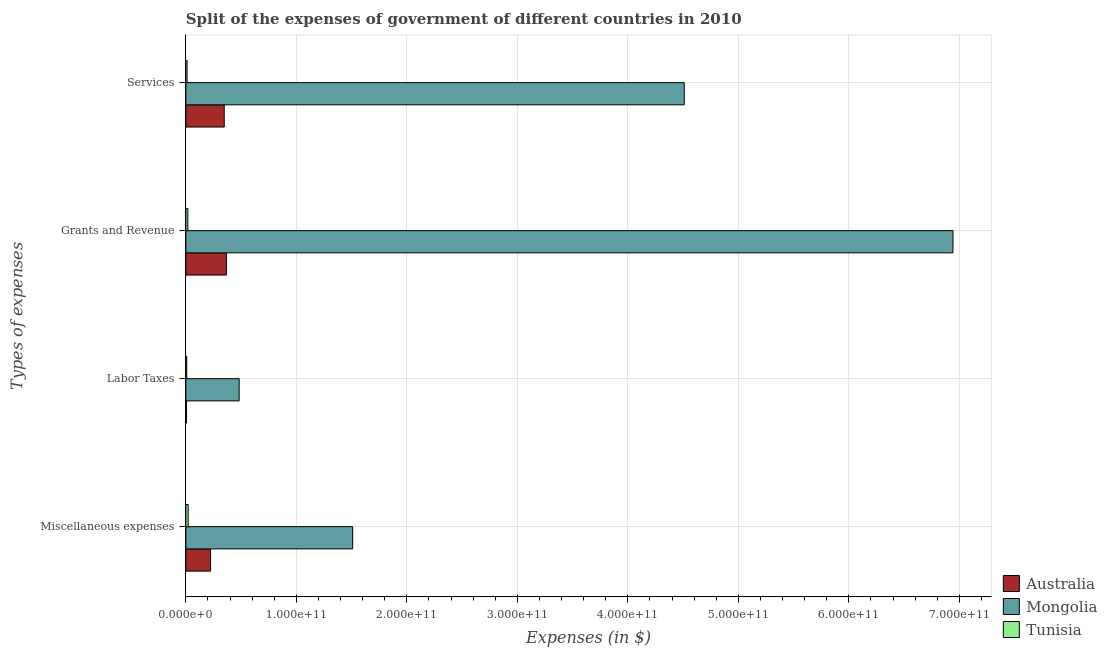How many groups of bars are there?
Keep it short and to the point. 4. Are the number of bars per tick equal to the number of legend labels?
Your answer should be compact. Yes. Are the number of bars on each tick of the Y-axis equal?
Your answer should be compact. Yes. How many bars are there on the 3rd tick from the bottom?
Your answer should be very brief. 3. What is the label of the 1st group of bars from the top?
Your answer should be compact. Services. What is the amount spent on services in Tunisia?
Make the answer very short. 1.09e+09. Across all countries, what is the maximum amount spent on services?
Your response must be concise. 4.51e+11. Across all countries, what is the minimum amount spent on labor taxes?
Ensure brevity in your answer.  5.19e+08. In which country was the amount spent on services maximum?
Make the answer very short. Mongolia. What is the total amount spent on services in the graph?
Keep it short and to the point. 4.87e+11. What is the difference between the amount spent on grants and revenue in Tunisia and that in Australia?
Ensure brevity in your answer.  -3.49e+1. What is the difference between the amount spent on services in Mongolia and the amount spent on labor taxes in Australia?
Make the answer very short. 4.51e+11. What is the average amount spent on services per country?
Ensure brevity in your answer.  1.62e+11. What is the difference between the amount spent on services and amount spent on grants and revenue in Mongolia?
Your answer should be very brief. -2.43e+11. In how many countries, is the amount spent on services greater than 660000000000 $?
Give a very brief answer. 0. What is the ratio of the amount spent on miscellaneous expenses in Australia to that in Tunisia?
Provide a succinct answer. 10.77. What is the difference between the highest and the second highest amount spent on miscellaneous expenses?
Provide a succinct answer. 1.29e+11. What is the difference between the highest and the lowest amount spent on labor taxes?
Offer a very short reply. 4.77e+1. Is the sum of the amount spent on grants and revenue in Mongolia and Tunisia greater than the maximum amount spent on labor taxes across all countries?
Your answer should be very brief. Yes. Is it the case that in every country, the sum of the amount spent on grants and revenue and amount spent on labor taxes is greater than the sum of amount spent on miscellaneous expenses and amount spent on services?
Your response must be concise. No. What does the 1st bar from the top in Grants and Revenue represents?
Your response must be concise. Tunisia. Is it the case that in every country, the sum of the amount spent on miscellaneous expenses and amount spent on labor taxes is greater than the amount spent on grants and revenue?
Your answer should be very brief. No. How many countries are there in the graph?
Your response must be concise. 3. What is the difference between two consecutive major ticks on the X-axis?
Make the answer very short. 1.00e+11. Are the values on the major ticks of X-axis written in scientific E-notation?
Keep it short and to the point. Yes. How many legend labels are there?
Provide a short and direct response. 3. What is the title of the graph?
Provide a short and direct response. Split of the expenses of government of different countries in 2010. Does "Angola" appear as one of the legend labels in the graph?
Offer a very short reply. No. What is the label or title of the X-axis?
Offer a very short reply. Expenses (in $). What is the label or title of the Y-axis?
Your answer should be very brief. Types of expenses. What is the Expenses (in $) in Australia in Miscellaneous expenses?
Your response must be concise. 2.23e+1. What is the Expenses (in $) in Mongolia in Miscellaneous expenses?
Make the answer very short. 1.51e+11. What is the Expenses (in $) of Tunisia in Miscellaneous expenses?
Provide a short and direct response. 2.07e+09. What is the Expenses (in $) of Australia in Labor Taxes?
Provide a succinct answer. 5.19e+08. What is the Expenses (in $) of Mongolia in Labor Taxes?
Ensure brevity in your answer.  4.82e+1. What is the Expenses (in $) in Tunisia in Labor Taxes?
Your answer should be compact. 7.76e+08. What is the Expenses (in $) of Australia in Grants and Revenue?
Keep it short and to the point. 3.67e+1. What is the Expenses (in $) of Mongolia in Grants and Revenue?
Offer a very short reply. 6.94e+11. What is the Expenses (in $) of Tunisia in Grants and Revenue?
Your answer should be compact. 1.78e+09. What is the Expenses (in $) of Australia in Services?
Offer a terse response. 3.47e+1. What is the Expenses (in $) in Mongolia in Services?
Your answer should be compact. 4.51e+11. What is the Expenses (in $) in Tunisia in Services?
Your answer should be very brief. 1.09e+09. Across all Types of expenses, what is the maximum Expenses (in $) of Australia?
Provide a succinct answer. 3.67e+1. Across all Types of expenses, what is the maximum Expenses (in $) of Mongolia?
Ensure brevity in your answer.  6.94e+11. Across all Types of expenses, what is the maximum Expenses (in $) in Tunisia?
Offer a terse response. 2.07e+09. Across all Types of expenses, what is the minimum Expenses (in $) in Australia?
Your answer should be very brief. 5.19e+08. Across all Types of expenses, what is the minimum Expenses (in $) of Mongolia?
Your response must be concise. 4.82e+1. Across all Types of expenses, what is the minimum Expenses (in $) of Tunisia?
Provide a succinct answer. 7.76e+08. What is the total Expenses (in $) of Australia in the graph?
Offer a terse response. 9.42e+1. What is the total Expenses (in $) of Mongolia in the graph?
Your answer should be very brief. 1.34e+12. What is the total Expenses (in $) in Tunisia in the graph?
Ensure brevity in your answer.  5.72e+09. What is the difference between the Expenses (in $) of Australia in Miscellaneous expenses and that in Labor Taxes?
Make the answer very short. 2.18e+1. What is the difference between the Expenses (in $) in Mongolia in Miscellaneous expenses and that in Labor Taxes?
Make the answer very short. 1.03e+11. What is the difference between the Expenses (in $) of Tunisia in Miscellaneous expenses and that in Labor Taxes?
Your answer should be compact. 1.30e+09. What is the difference between the Expenses (in $) in Australia in Miscellaneous expenses and that in Grants and Revenue?
Make the answer very short. -1.43e+1. What is the difference between the Expenses (in $) of Mongolia in Miscellaneous expenses and that in Grants and Revenue?
Offer a very short reply. -5.43e+11. What is the difference between the Expenses (in $) in Tunisia in Miscellaneous expenses and that in Grants and Revenue?
Offer a very short reply. 2.98e+08. What is the difference between the Expenses (in $) of Australia in Miscellaneous expenses and that in Services?
Keep it short and to the point. -1.24e+1. What is the difference between the Expenses (in $) in Mongolia in Miscellaneous expenses and that in Services?
Offer a very short reply. -3.00e+11. What is the difference between the Expenses (in $) in Tunisia in Miscellaneous expenses and that in Services?
Your answer should be very brief. 9.80e+08. What is the difference between the Expenses (in $) of Australia in Labor Taxes and that in Grants and Revenue?
Give a very brief answer. -3.61e+1. What is the difference between the Expenses (in $) in Mongolia in Labor Taxes and that in Grants and Revenue?
Make the answer very short. -6.46e+11. What is the difference between the Expenses (in $) of Tunisia in Labor Taxes and that in Grants and Revenue?
Keep it short and to the point. -1.00e+09. What is the difference between the Expenses (in $) in Australia in Labor Taxes and that in Services?
Provide a short and direct response. -3.42e+1. What is the difference between the Expenses (in $) of Mongolia in Labor Taxes and that in Services?
Ensure brevity in your answer.  -4.03e+11. What is the difference between the Expenses (in $) in Tunisia in Labor Taxes and that in Services?
Ensure brevity in your answer.  -3.19e+08. What is the difference between the Expenses (in $) of Australia in Grants and Revenue and that in Services?
Provide a succinct answer. 1.93e+09. What is the difference between the Expenses (in $) of Mongolia in Grants and Revenue and that in Services?
Keep it short and to the point. 2.43e+11. What is the difference between the Expenses (in $) in Tunisia in Grants and Revenue and that in Services?
Make the answer very short. 6.82e+08. What is the difference between the Expenses (in $) in Australia in Miscellaneous expenses and the Expenses (in $) in Mongolia in Labor Taxes?
Provide a short and direct response. -2.59e+1. What is the difference between the Expenses (in $) of Australia in Miscellaneous expenses and the Expenses (in $) of Tunisia in Labor Taxes?
Your answer should be very brief. 2.16e+1. What is the difference between the Expenses (in $) of Mongolia in Miscellaneous expenses and the Expenses (in $) of Tunisia in Labor Taxes?
Your answer should be very brief. 1.50e+11. What is the difference between the Expenses (in $) in Australia in Miscellaneous expenses and the Expenses (in $) in Mongolia in Grants and Revenue?
Give a very brief answer. -6.72e+11. What is the difference between the Expenses (in $) of Australia in Miscellaneous expenses and the Expenses (in $) of Tunisia in Grants and Revenue?
Give a very brief answer. 2.06e+1. What is the difference between the Expenses (in $) in Mongolia in Miscellaneous expenses and the Expenses (in $) in Tunisia in Grants and Revenue?
Offer a very short reply. 1.49e+11. What is the difference between the Expenses (in $) of Australia in Miscellaneous expenses and the Expenses (in $) of Mongolia in Services?
Keep it short and to the point. -4.29e+11. What is the difference between the Expenses (in $) in Australia in Miscellaneous expenses and the Expenses (in $) in Tunisia in Services?
Your response must be concise. 2.12e+1. What is the difference between the Expenses (in $) of Mongolia in Miscellaneous expenses and the Expenses (in $) of Tunisia in Services?
Provide a short and direct response. 1.50e+11. What is the difference between the Expenses (in $) of Australia in Labor Taxes and the Expenses (in $) of Mongolia in Grants and Revenue?
Provide a short and direct response. -6.94e+11. What is the difference between the Expenses (in $) of Australia in Labor Taxes and the Expenses (in $) of Tunisia in Grants and Revenue?
Give a very brief answer. -1.26e+09. What is the difference between the Expenses (in $) in Mongolia in Labor Taxes and the Expenses (in $) in Tunisia in Grants and Revenue?
Offer a very short reply. 4.64e+1. What is the difference between the Expenses (in $) in Australia in Labor Taxes and the Expenses (in $) in Mongolia in Services?
Offer a very short reply. -4.51e+11. What is the difference between the Expenses (in $) in Australia in Labor Taxes and the Expenses (in $) in Tunisia in Services?
Your answer should be very brief. -5.76e+08. What is the difference between the Expenses (in $) of Mongolia in Labor Taxes and the Expenses (in $) of Tunisia in Services?
Offer a terse response. 4.71e+1. What is the difference between the Expenses (in $) of Australia in Grants and Revenue and the Expenses (in $) of Mongolia in Services?
Your answer should be very brief. -4.14e+11. What is the difference between the Expenses (in $) of Australia in Grants and Revenue and the Expenses (in $) of Tunisia in Services?
Offer a terse response. 3.56e+1. What is the difference between the Expenses (in $) in Mongolia in Grants and Revenue and the Expenses (in $) in Tunisia in Services?
Your answer should be very brief. 6.93e+11. What is the average Expenses (in $) of Australia per Types of expenses?
Make the answer very short. 2.36e+1. What is the average Expenses (in $) in Mongolia per Types of expenses?
Your answer should be very brief. 3.36e+11. What is the average Expenses (in $) of Tunisia per Types of expenses?
Keep it short and to the point. 1.43e+09. What is the difference between the Expenses (in $) of Australia and Expenses (in $) of Mongolia in Miscellaneous expenses?
Your answer should be very brief. -1.29e+11. What is the difference between the Expenses (in $) in Australia and Expenses (in $) in Tunisia in Miscellaneous expenses?
Give a very brief answer. 2.03e+1. What is the difference between the Expenses (in $) in Mongolia and Expenses (in $) in Tunisia in Miscellaneous expenses?
Offer a very short reply. 1.49e+11. What is the difference between the Expenses (in $) of Australia and Expenses (in $) of Mongolia in Labor Taxes?
Offer a very short reply. -4.77e+1. What is the difference between the Expenses (in $) of Australia and Expenses (in $) of Tunisia in Labor Taxes?
Your answer should be very brief. -2.57e+08. What is the difference between the Expenses (in $) in Mongolia and Expenses (in $) in Tunisia in Labor Taxes?
Provide a short and direct response. 4.74e+1. What is the difference between the Expenses (in $) of Australia and Expenses (in $) of Mongolia in Grants and Revenue?
Offer a very short reply. -6.58e+11. What is the difference between the Expenses (in $) in Australia and Expenses (in $) in Tunisia in Grants and Revenue?
Your answer should be very brief. 3.49e+1. What is the difference between the Expenses (in $) in Mongolia and Expenses (in $) in Tunisia in Grants and Revenue?
Your response must be concise. 6.92e+11. What is the difference between the Expenses (in $) in Australia and Expenses (in $) in Mongolia in Services?
Your answer should be very brief. -4.16e+11. What is the difference between the Expenses (in $) in Australia and Expenses (in $) in Tunisia in Services?
Your answer should be very brief. 3.36e+1. What is the difference between the Expenses (in $) in Mongolia and Expenses (in $) in Tunisia in Services?
Provide a succinct answer. 4.50e+11. What is the ratio of the Expenses (in $) of Australia in Miscellaneous expenses to that in Labor Taxes?
Your answer should be compact. 43.04. What is the ratio of the Expenses (in $) in Mongolia in Miscellaneous expenses to that in Labor Taxes?
Your answer should be very brief. 3.13. What is the ratio of the Expenses (in $) in Tunisia in Miscellaneous expenses to that in Labor Taxes?
Keep it short and to the point. 2.67. What is the ratio of the Expenses (in $) in Australia in Miscellaneous expenses to that in Grants and Revenue?
Provide a succinct answer. 0.61. What is the ratio of the Expenses (in $) of Mongolia in Miscellaneous expenses to that in Grants and Revenue?
Make the answer very short. 0.22. What is the ratio of the Expenses (in $) in Tunisia in Miscellaneous expenses to that in Grants and Revenue?
Your answer should be very brief. 1.17. What is the ratio of the Expenses (in $) of Australia in Miscellaneous expenses to that in Services?
Provide a succinct answer. 0.64. What is the ratio of the Expenses (in $) in Mongolia in Miscellaneous expenses to that in Services?
Provide a succinct answer. 0.33. What is the ratio of the Expenses (in $) in Tunisia in Miscellaneous expenses to that in Services?
Provide a succinct answer. 1.89. What is the ratio of the Expenses (in $) in Australia in Labor Taxes to that in Grants and Revenue?
Offer a terse response. 0.01. What is the ratio of the Expenses (in $) in Mongolia in Labor Taxes to that in Grants and Revenue?
Your answer should be very brief. 0.07. What is the ratio of the Expenses (in $) of Tunisia in Labor Taxes to that in Grants and Revenue?
Ensure brevity in your answer.  0.44. What is the ratio of the Expenses (in $) in Australia in Labor Taxes to that in Services?
Your answer should be very brief. 0.01. What is the ratio of the Expenses (in $) in Mongolia in Labor Taxes to that in Services?
Your response must be concise. 0.11. What is the ratio of the Expenses (in $) in Tunisia in Labor Taxes to that in Services?
Keep it short and to the point. 0.71. What is the ratio of the Expenses (in $) of Australia in Grants and Revenue to that in Services?
Provide a succinct answer. 1.06. What is the ratio of the Expenses (in $) of Mongolia in Grants and Revenue to that in Services?
Provide a succinct answer. 1.54. What is the ratio of the Expenses (in $) of Tunisia in Grants and Revenue to that in Services?
Your response must be concise. 1.62. What is the difference between the highest and the second highest Expenses (in $) in Australia?
Make the answer very short. 1.93e+09. What is the difference between the highest and the second highest Expenses (in $) in Mongolia?
Provide a succinct answer. 2.43e+11. What is the difference between the highest and the second highest Expenses (in $) in Tunisia?
Offer a terse response. 2.98e+08. What is the difference between the highest and the lowest Expenses (in $) of Australia?
Provide a short and direct response. 3.61e+1. What is the difference between the highest and the lowest Expenses (in $) of Mongolia?
Provide a succinct answer. 6.46e+11. What is the difference between the highest and the lowest Expenses (in $) of Tunisia?
Your response must be concise. 1.30e+09. 